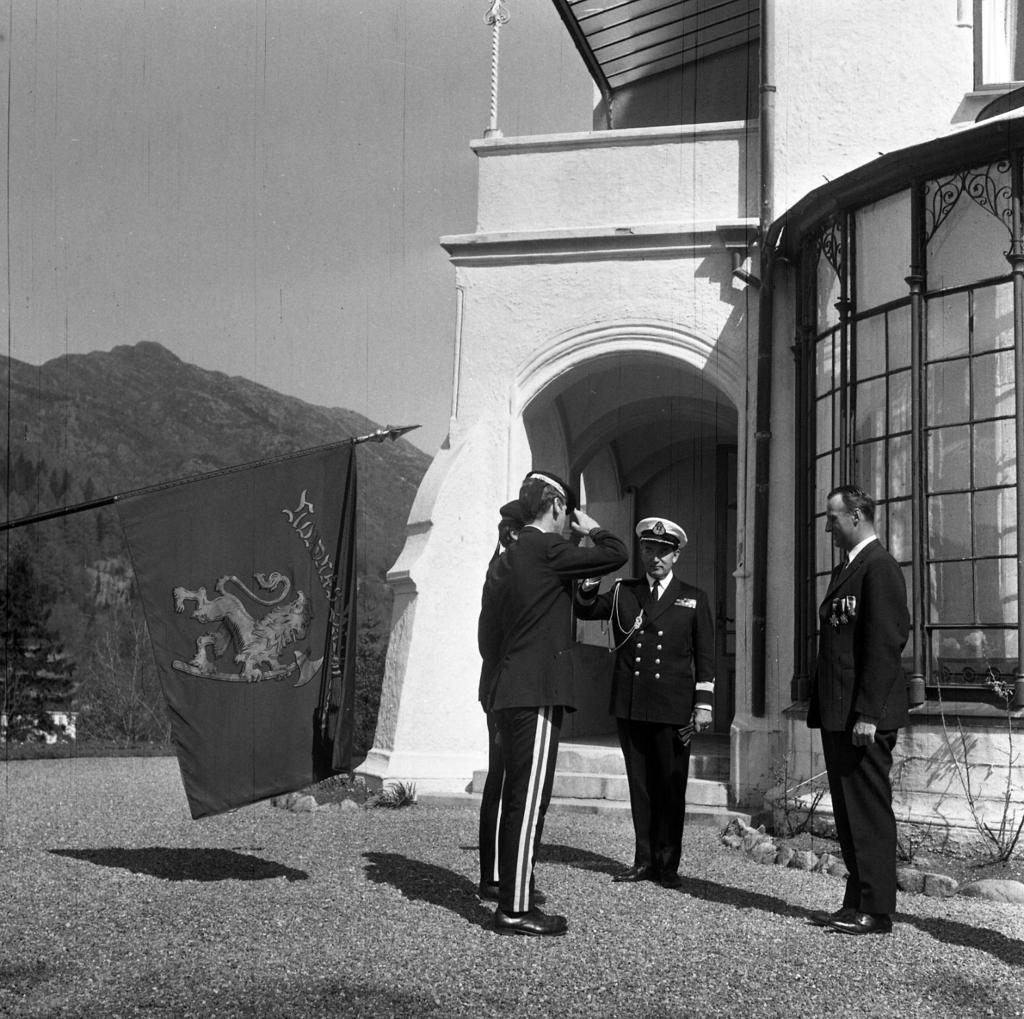Describe this image in one or two sentences. This is a black and white image. In this image, we can see people standing on the path. In the background, we can see house, wall, pillar, plants, pipe, glass objects, hill, trees, rod, railings, walkway and sky. On the left side of the image, we can see a stick with a flag. 